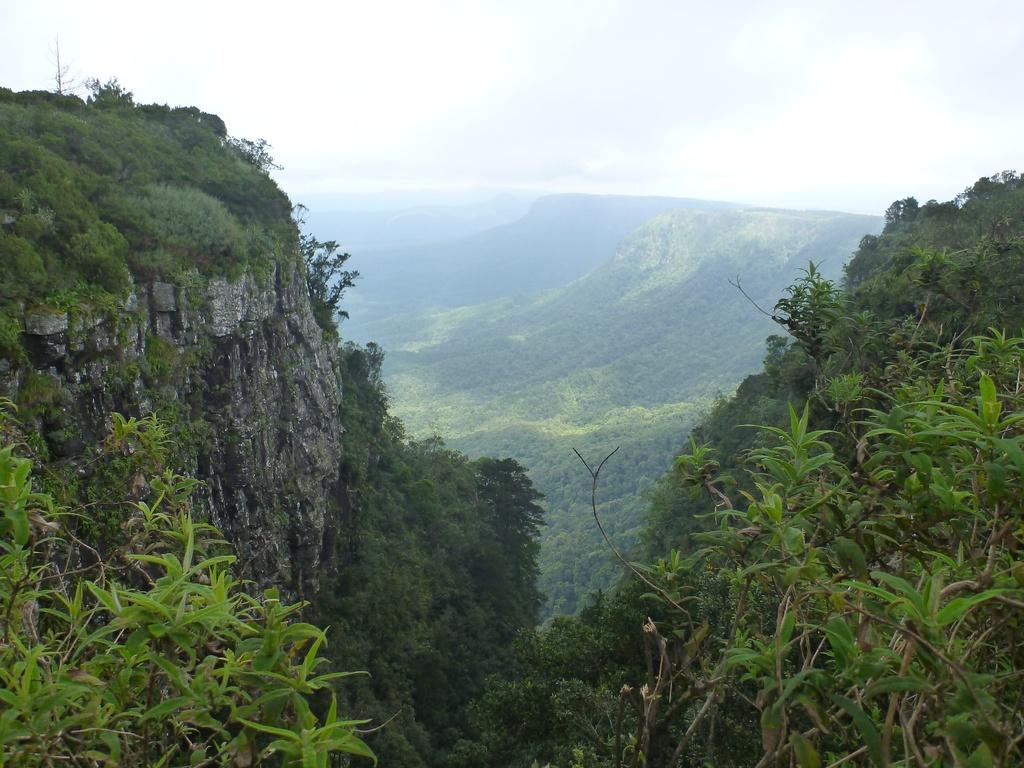What type of natural landform can be seen in the image? The image contains mountains. What type of vegetation is present in the image? There are trees and plants with leaves and branches in the image. What part of the natural environment is visible in the image? The sky is visible in the image. What type of pie is being served on a plate in the image? There is no pie present in the image; it features mountains, trees, plants, and the sky. 